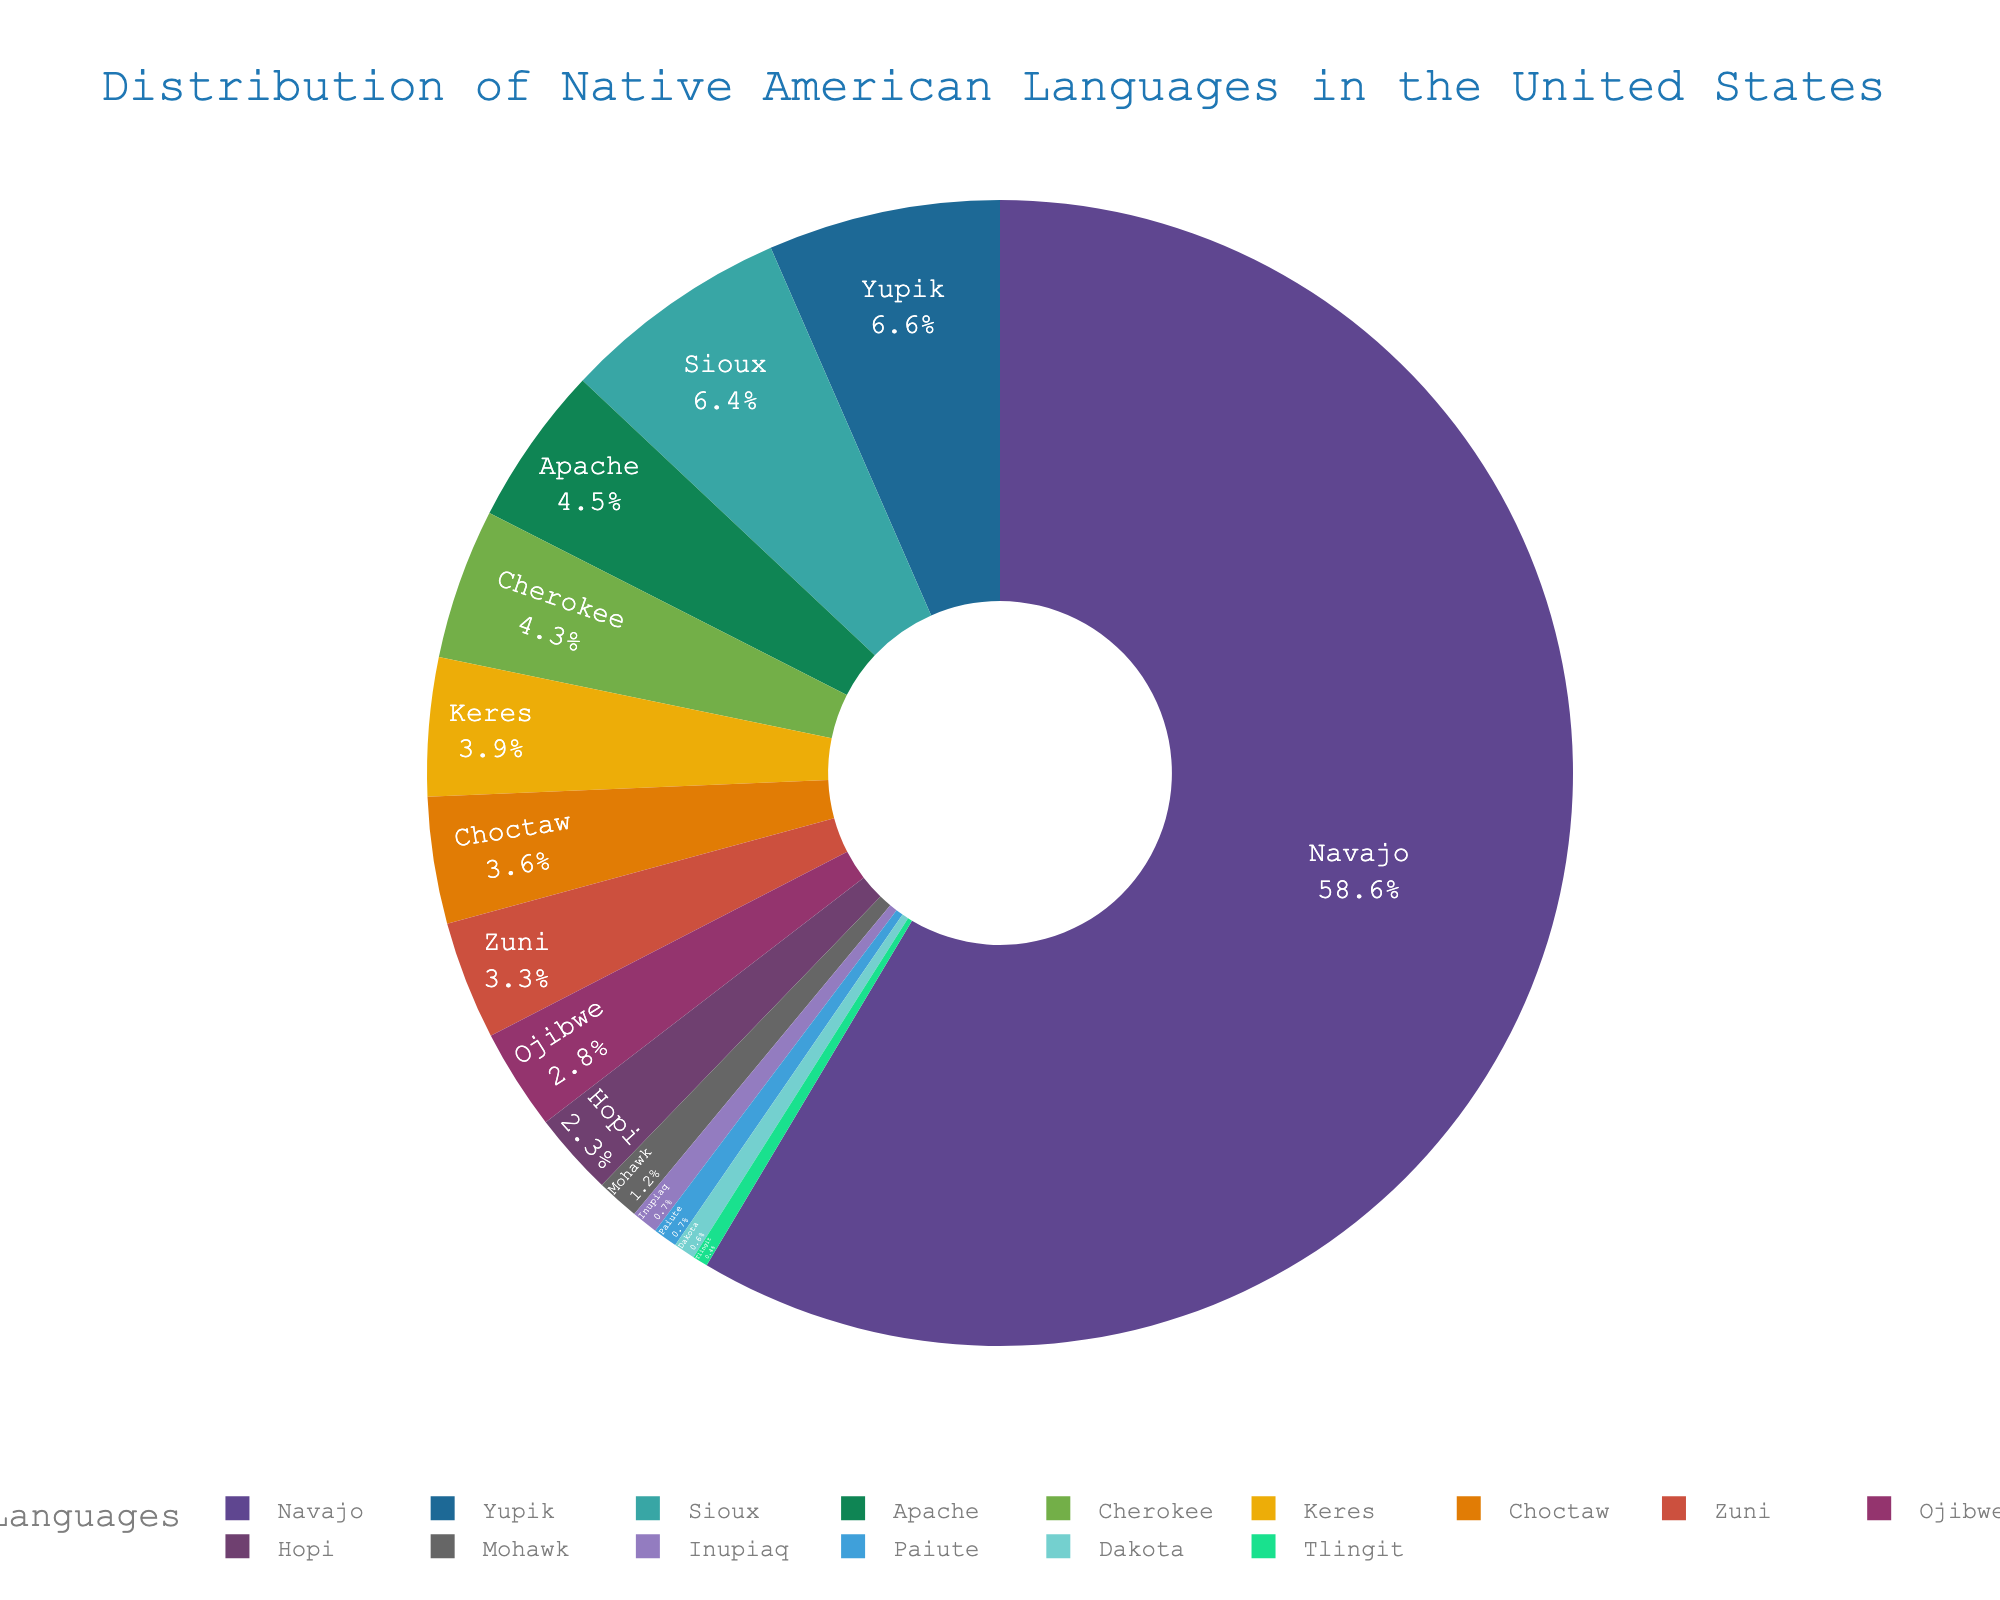Which language has the highest number of speakers? According to the visual information, the language with the largest segment on the pie chart represents the language with the most speakers. This is the Navajo language.
Answer: Navajo Which language has the fewest number of speakers? The smallest segment on the pie chart represents the language with the fewest speakers. This is the Tlingit language.
Answer: Tlingit How do the number of Sioux speakers compare to the number of Yupik speakers? By looking at the relative size of the segments for Sioux and Yupik, it is clear that the Sioux segment is slightly smaller than the Yupik segment.
Answer: Fewer What is the combined percentage of speakers for Keres and Zuni languages? To find the combined percentage, look at the individual percentages for Keres and Zuni on the pie chart and add them together. The sum of their percentages will be the combined percentage.
Answer: Keres % + Zuni % Which colors represent the Navajo and Cherokee languages on the pie chart? Identify the segments in the pie chart that correspond to Navajo and Cherokee and note the colors used for each.
Answer: Navajo: __, Cherokee: __ How does the number of Apache speakers compare to the number of Choctaw speakers? Look at the segments for Apache and Choctaw on the pie chart. By comparing their sizes, it's evident that the segment representing Apache is slightly larger than the segment for Choctaw.
Answer: More What is the approximate percentage of speakers for the Hopi language? Identify the segment for the Hopi language on the pie chart. Hover over the segment or look at the segment's label to find the percentage.
Answer: Hopi % Which two languages have a nearly equal number of speakers? Look at the pie chart and identify two segments that are almost equal in size. These represent languages with a nearly equal number of speakers.
Answer: Apache and Choctaw What is the visual difference between the segment of Navajo and Paiute? The segment for Navajo is considerably larger than the one for Paiute, indicating Navajo has a significantly larger number of speakers compared to Paiute.
Answer: Larger Which three languages have speaker numbers closest to each other? Examine the segments on the pie chart and identify three segments that are similar in size. These languages have speaker numbers closest to each other.
Answer: Inupiaq, Paiute, Dakota 